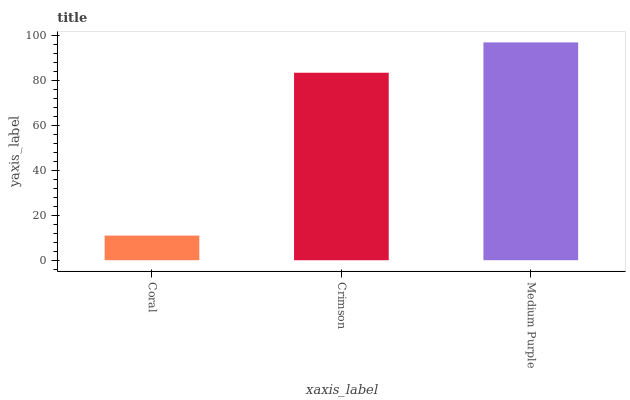Is Coral the minimum?
Answer yes or no. Yes. Is Medium Purple the maximum?
Answer yes or no. Yes. Is Crimson the minimum?
Answer yes or no. No. Is Crimson the maximum?
Answer yes or no. No. Is Crimson greater than Coral?
Answer yes or no. Yes. Is Coral less than Crimson?
Answer yes or no. Yes. Is Coral greater than Crimson?
Answer yes or no. No. Is Crimson less than Coral?
Answer yes or no. No. Is Crimson the high median?
Answer yes or no. Yes. Is Crimson the low median?
Answer yes or no. Yes. Is Medium Purple the high median?
Answer yes or no. No. Is Medium Purple the low median?
Answer yes or no. No. 